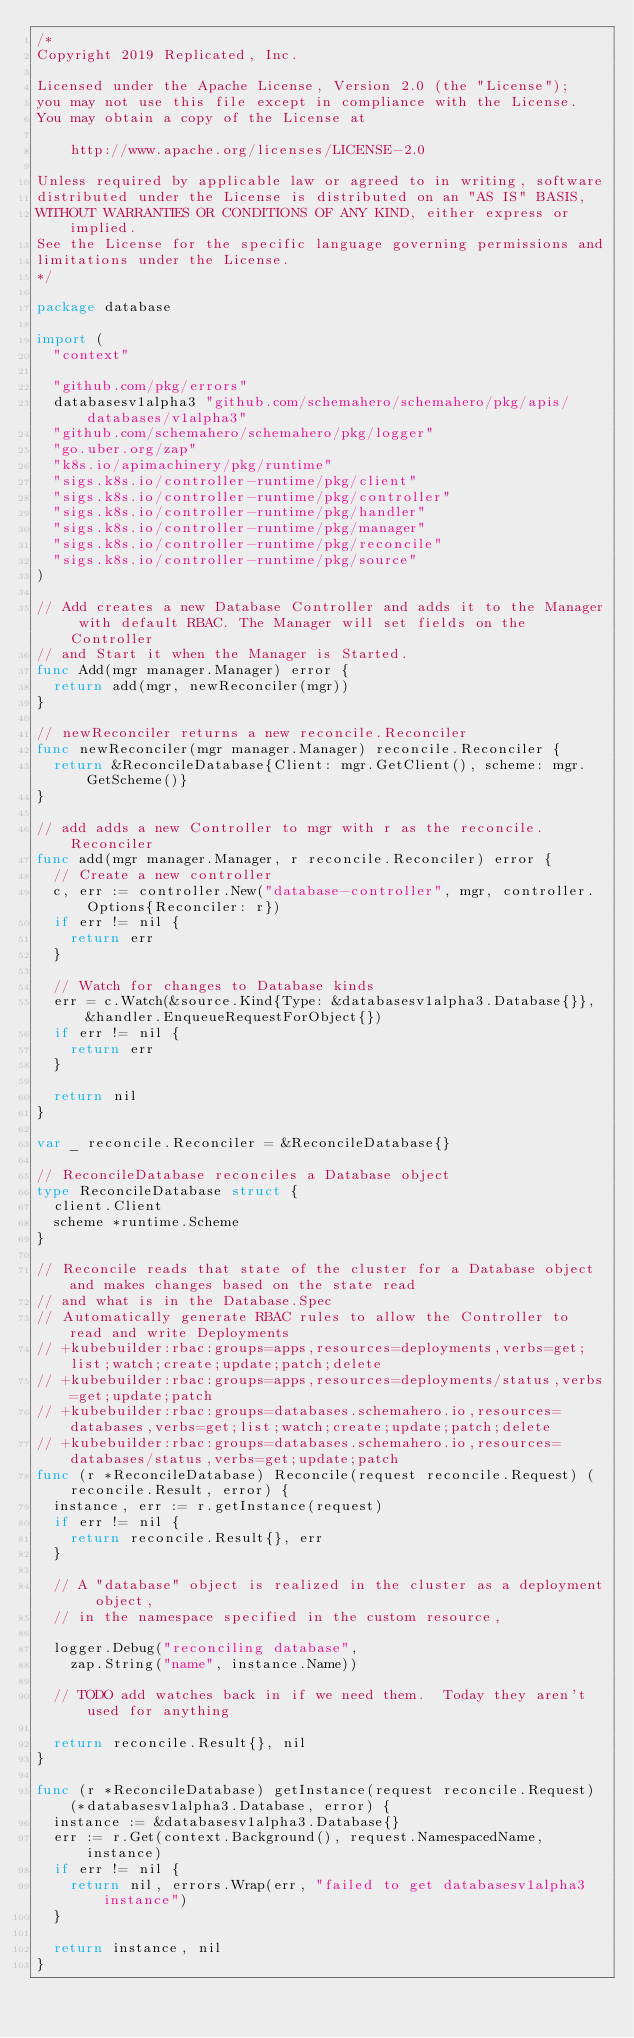Convert code to text. <code><loc_0><loc_0><loc_500><loc_500><_Go_>/*
Copyright 2019 Replicated, Inc.

Licensed under the Apache License, Version 2.0 (the "License");
you may not use this file except in compliance with the License.
You may obtain a copy of the License at

    http://www.apache.org/licenses/LICENSE-2.0

Unless required by applicable law or agreed to in writing, software
distributed under the License is distributed on an "AS IS" BASIS,
WITHOUT WARRANTIES OR CONDITIONS OF ANY KIND, either express or implied.
See the License for the specific language governing permissions and
limitations under the License.
*/

package database

import (
	"context"

	"github.com/pkg/errors"
	databasesv1alpha3 "github.com/schemahero/schemahero/pkg/apis/databases/v1alpha3"
	"github.com/schemahero/schemahero/pkg/logger"
	"go.uber.org/zap"
	"k8s.io/apimachinery/pkg/runtime"
	"sigs.k8s.io/controller-runtime/pkg/client"
	"sigs.k8s.io/controller-runtime/pkg/controller"
	"sigs.k8s.io/controller-runtime/pkg/handler"
	"sigs.k8s.io/controller-runtime/pkg/manager"
	"sigs.k8s.io/controller-runtime/pkg/reconcile"
	"sigs.k8s.io/controller-runtime/pkg/source"
)

// Add creates a new Database Controller and adds it to the Manager with default RBAC. The Manager will set fields on the Controller
// and Start it when the Manager is Started.
func Add(mgr manager.Manager) error {
	return add(mgr, newReconciler(mgr))
}

// newReconciler returns a new reconcile.Reconciler
func newReconciler(mgr manager.Manager) reconcile.Reconciler {
	return &ReconcileDatabase{Client: mgr.GetClient(), scheme: mgr.GetScheme()}
}

// add adds a new Controller to mgr with r as the reconcile.Reconciler
func add(mgr manager.Manager, r reconcile.Reconciler) error {
	// Create a new controller
	c, err := controller.New("database-controller", mgr, controller.Options{Reconciler: r})
	if err != nil {
		return err
	}

	// Watch for changes to Database kinds
	err = c.Watch(&source.Kind{Type: &databasesv1alpha3.Database{}}, &handler.EnqueueRequestForObject{})
	if err != nil {
		return err
	}

	return nil
}

var _ reconcile.Reconciler = &ReconcileDatabase{}

// ReconcileDatabase reconciles a Database object
type ReconcileDatabase struct {
	client.Client
	scheme *runtime.Scheme
}

// Reconcile reads that state of the cluster for a Database object and makes changes based on the state read
// and what is in the Database.Spec
// Automatically generate RBAC rules to allow the Controller to read and write Deployments
// +kubebuilder:rbac:groups=apps,resources=deployments,verbs=get;list;watch;create;update;patch;delete
// +kubebuilder:rbac:groups=apps,resources=deployments/status,verbs=get;update;patch
// +kubebuilder:rbac:groups=databases.schemahero.io,resources=databases,verbs=get;list;watch;create;update;patch;delete
// +kubebuilder:rbac:groups=databases.schemahero.io,resources=databases/status,verbs=get;update;patch
func (r *ReconcileDatabase) Reconcile(request reconcile.Request) (reconcile.Result, error) {
	instance, err := r.getInstance(request)
	if err != nil {
		return reconcile.Result{}, err
	}

	// A "database" object is realized in the cluster as a deployment object,
	// in the namespace specified in the custom resource,

	logger.Debug("reconciling database",
		zap.String("name", instance.Name))

	// TODO add watches back in if we need them.  Today they aren't used for anything

	return reconcile.Result{}, nil
}

func (r *ReconcileDatabase) getInstance(request reconcile.Request) (*databasesv1alpha3.Database, error) {
	instance := &databasesv1alpha3.Database{}
	err := r.Get(context.Background(), request.NamespacedName, instance)
	if err != nil {
		return nil, errors.Wrap(err, "failed to get databasesv1alpha3 instance")
	}

	return instance, nil
}
</code> 